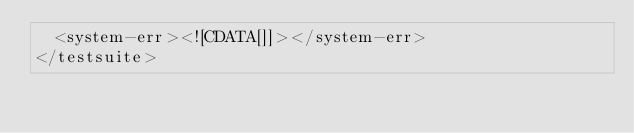<code> <loc_0><loc_0><loc_500><loc_500><_XML_>  <system-err><![CDATA[]]></system-err>
</testsuite>
</code> 